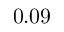Convert formula to latex. <formula><loc_0><loc_0><loc_500><loc_500>0 . 0 9</formula> 